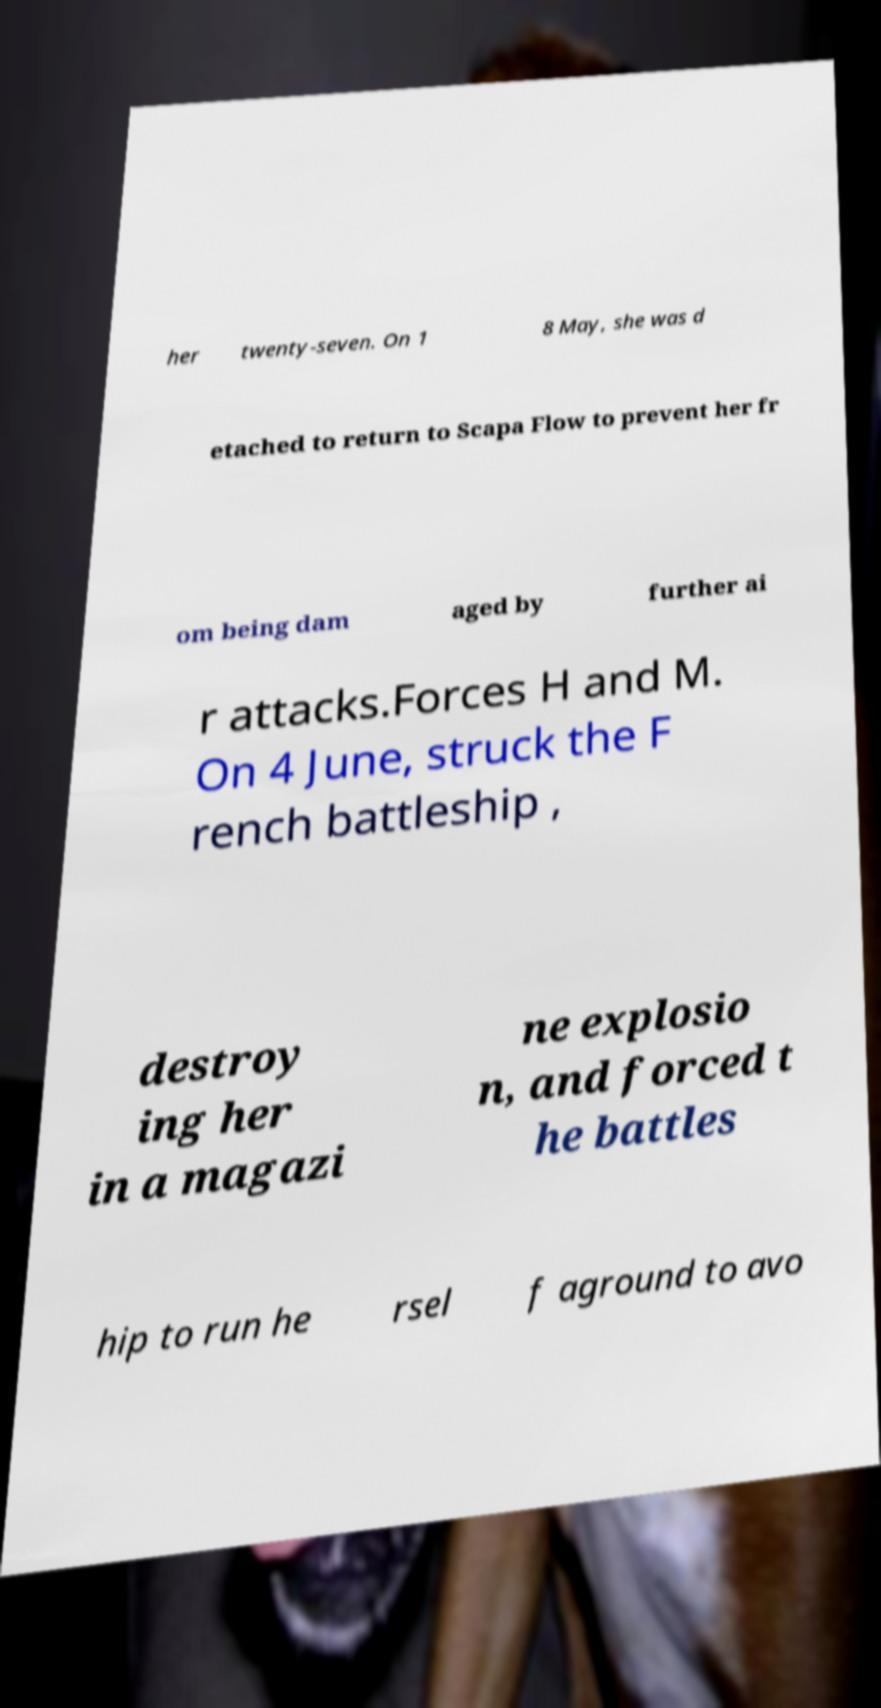Please read and relay the text visible in this image. What does it say? her twenty-seven. On 1 8 May, she was d etached to return to Scapa Flow to prevent her fr om being dam aged by further ai r attacks.Forces H and M. On 4 June, struck the F rench battleship , destroy ing her in a magazi ne explosio n, and forced t he battles hip to run he rsel f aground to avo 